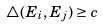<formula> <loc_0><loc_0><loc_500><loc_500>\bigtriangleup ( E _ { i } , E _ { j } ) \geq c</formula> 